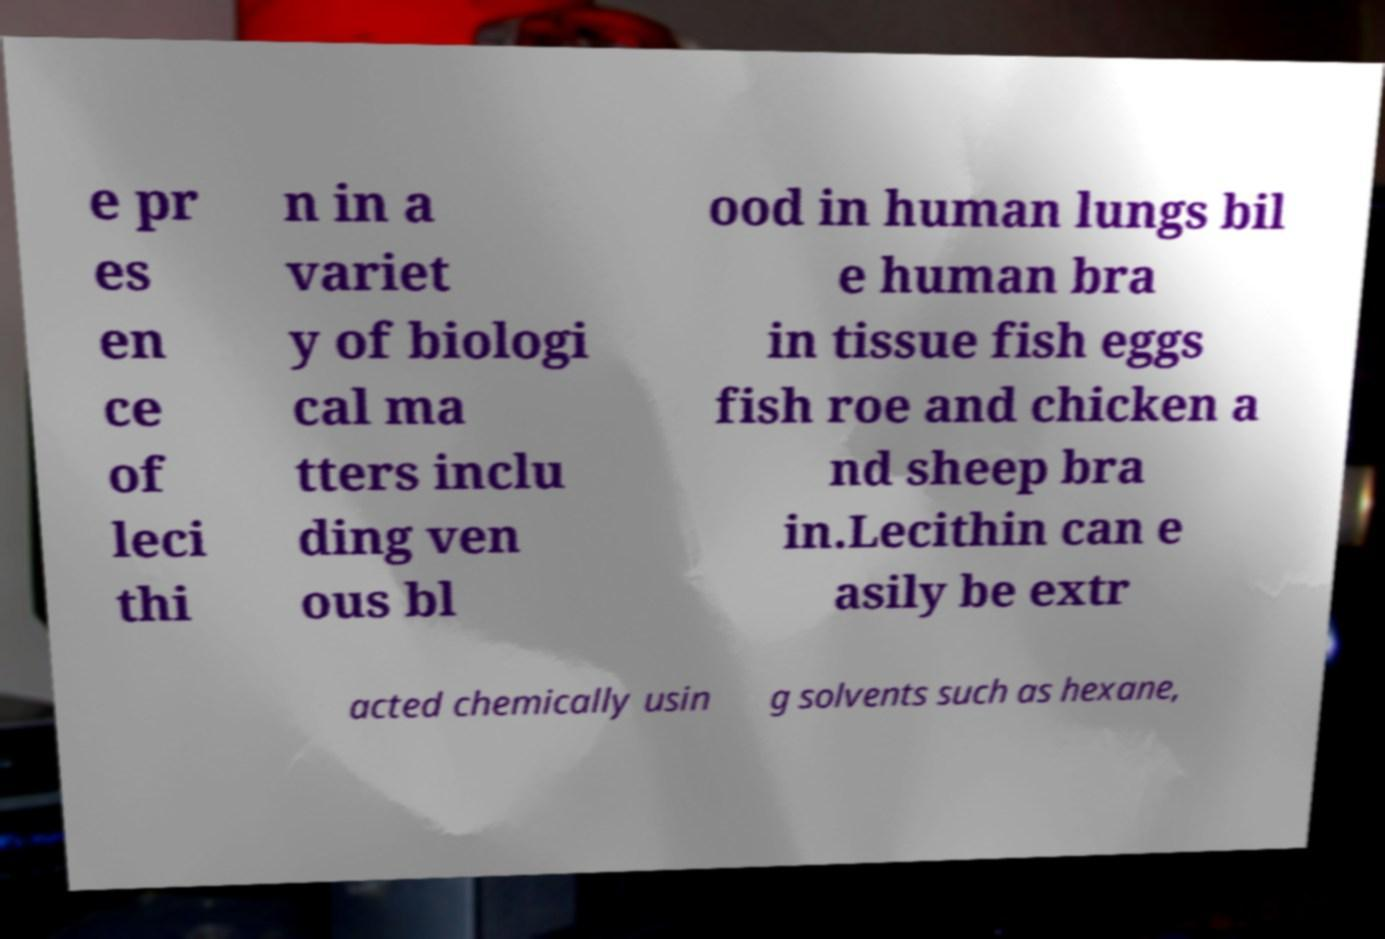Can you read and provide the text displayed in the image?This photo seems to have some interesting text. Can you extract and type it out for me? e pr es en ce of leci thi n in a variet y of biologi cal ma tters inclu ding ven ous bl ood in human lungs bil e human bra in tissue fish eggs fish roe and chicken a nd sheep bra in.Lecithin can e asily be extr acted chemically usin g solvents such as hexane, 